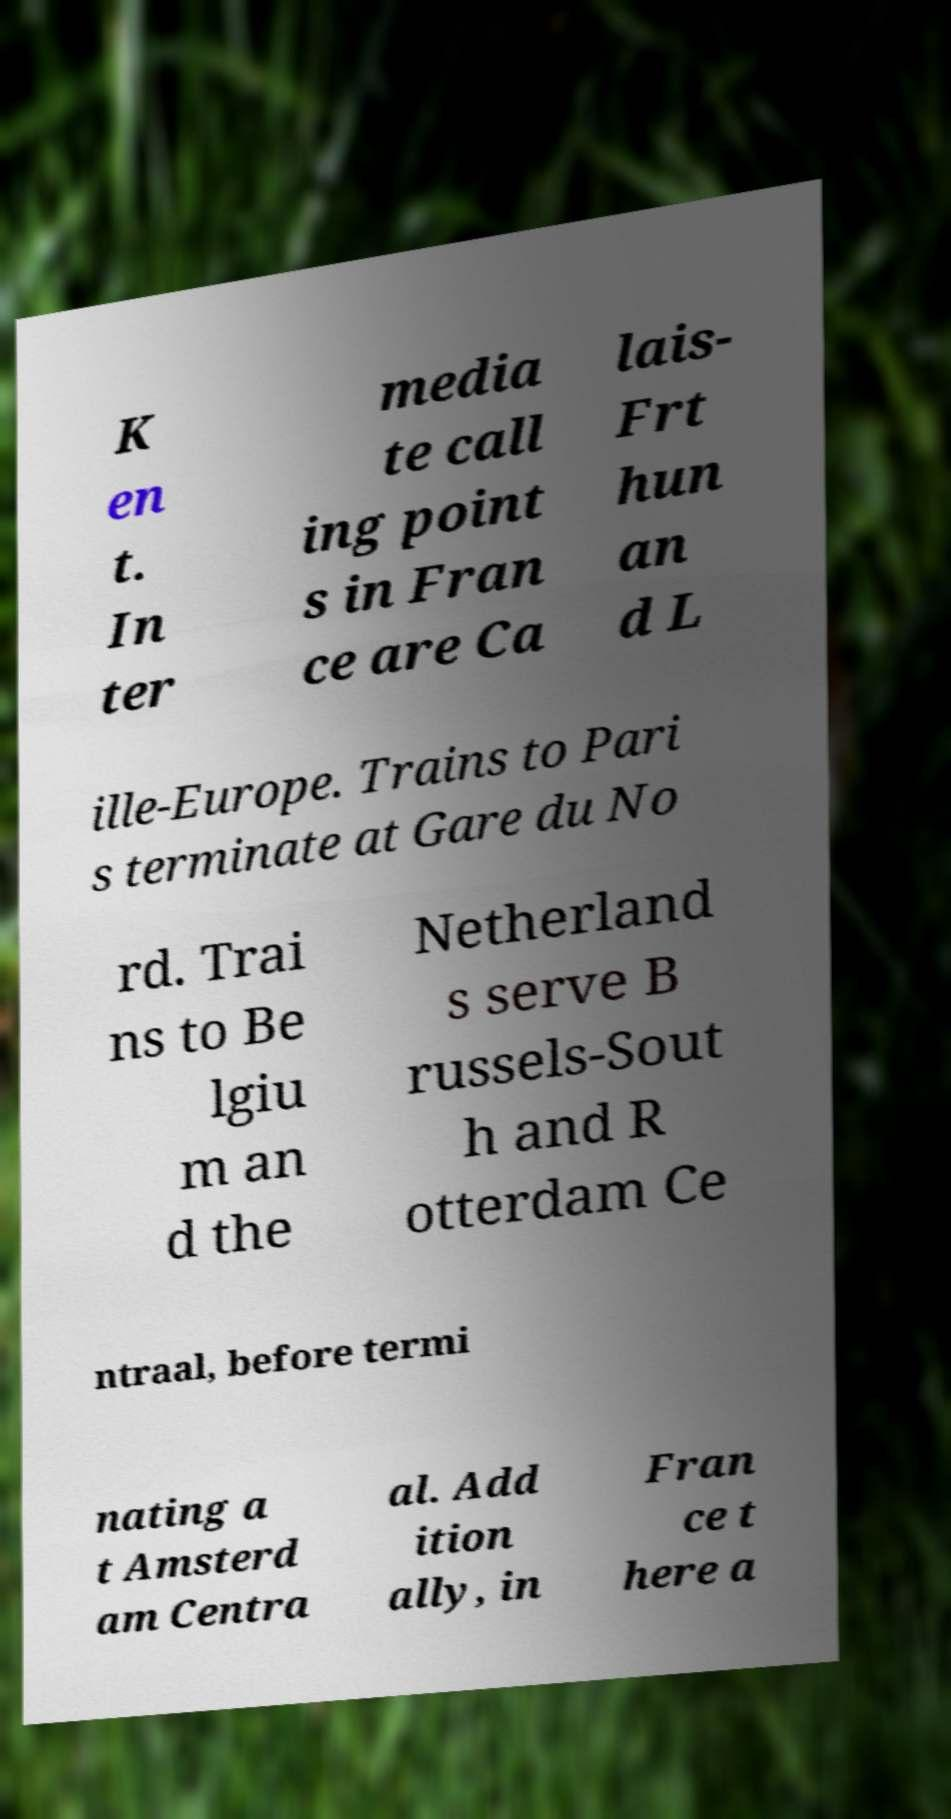For documentation purposes, I need the text within this image transcribed. Could you provide that? K en t. In ter media te call ing point s in Fran ce are Ca lais- Frt hun an d L ille-Europe. Trains to Pari s terminate at Gare du No rd. Trai ns to Be lgiu m an d the Netherland s serve B russels-Sout h and R otterdam Ce ntraal, before termi nating a t Amsterd am Centra al. Add ition ally, in Fran ce t here a 